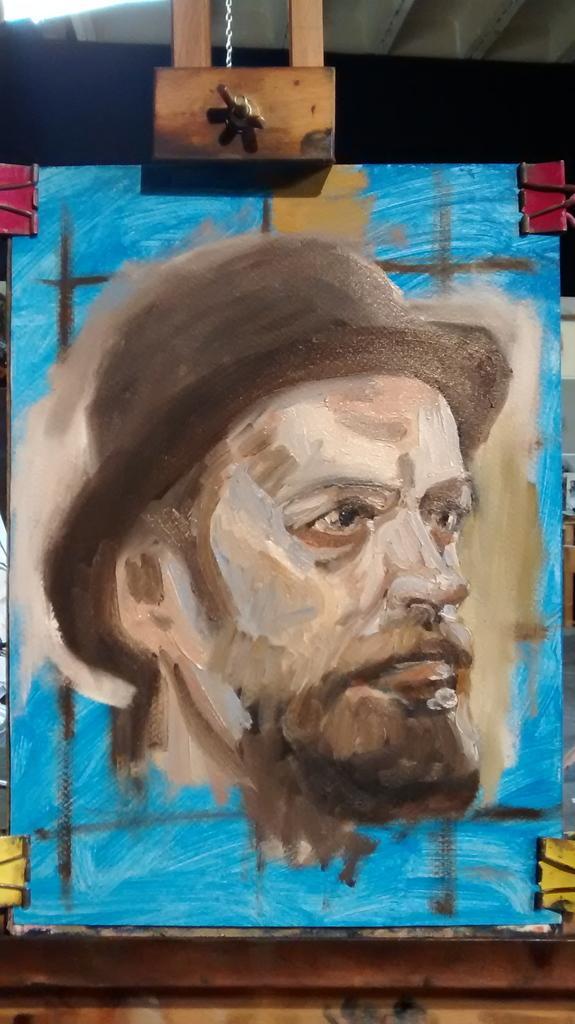Could you give a brief overview of what you see in this image? There is a board with a painting of a person's head with a hat. On the sides there are clips. At the top there is a wooden object. 